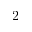<formula> <loc_0><loc_0><loc_500><loc_500>2</formula> 